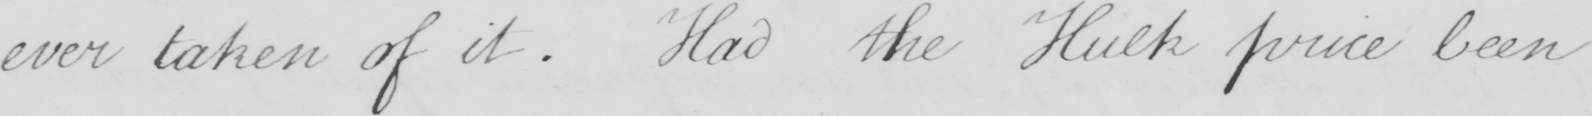What does this handwritten line say? ever taken of it . Had the Hulk price been 